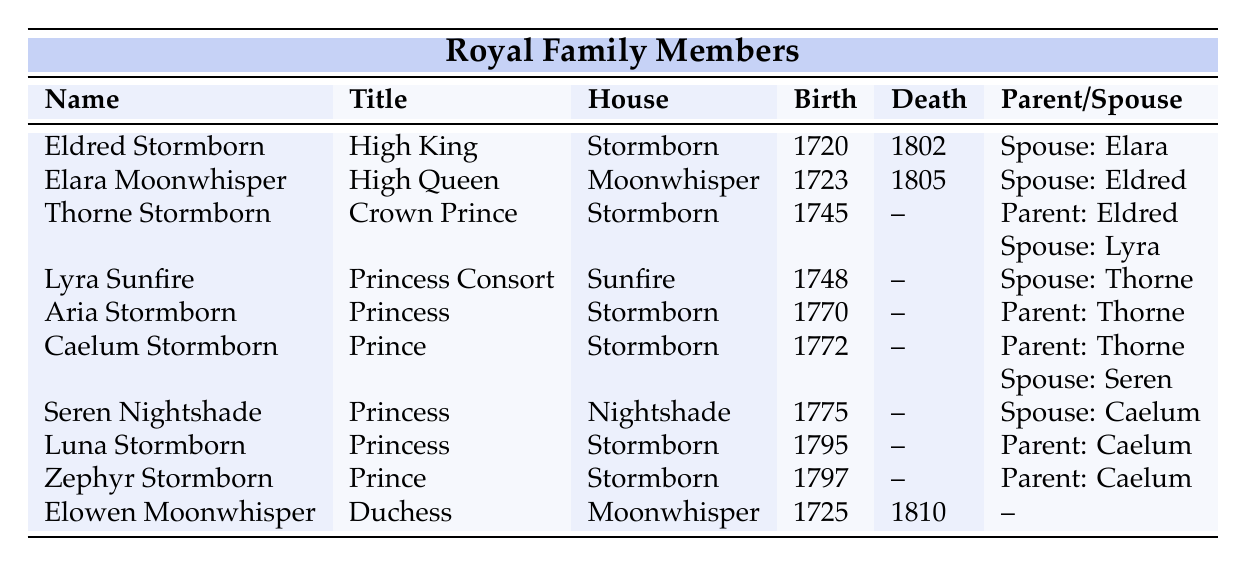What is the title of Eldred Stormborn? By looking at the table, we can see that Eldred Stormborn's title is listed directly next to his name under the "Title" column.
Answer: High King Which house does Lyra Sunfire belong to? The table shows that Lyra Sunfire is associated with the Sunfire house as indicated in the "House" column next to her name.
Answer: Sunfire Who are the children of Thorne Stormborn? To answer this, we look for the entries where Thorne is listed as a parent. The table shows two entries: Aria Stormborn and Caelum Stormborn are children of Thorne.
Answer: Aria Stormborn and Caelum Stormborn Is Elowen Moonwhisper still alive? Checking the "Death" column for Elowen Moonwhisper, we see that her death year is 1810. Given the lack of a current year noted in the dataset, we can infer that she is deceased.
Answer: No How many members of the Stormborn house appear in the table? We count the entries under the "House" column that state "Stormborn." The members are Eldred, Thorne, Aria, Caelum, Luna, and Zephyr, totaling six individuals.
Answer: 6 What is the birth year of the youngest child of Thorne Stormborn? First, we find the children of Thorne: Aria (1770), Caelum (1772). Then, we check the children of Caelum, who are Luna (1795) and Zephyr (1797). The youngest child of Thorne is Caelum's youngest child, Zephyr, who was born in 1797.
Answer: 1797 Which member of the royal family has the longest lifespan? By comparing the death and birth years of the family members with those who have death years noted, Eldred Stormborn (1720 - 1802) lived for 82 years, while Elowen Moonwhisper (1725 - 1810) lived for 85 years. Thus, Elowen Moonwhisper had the longest lifespan.
Answer: Elowen Moonwhisper Are there any members from the Nightshade house in the table? Looking through the "House" column, we can find Seren Nightshade listed there. Thus, there is at least one member from the Nightshade house.
Answer: Yes 